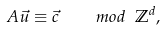Convert formula to latex. <formula><loc_0><loc_0><loc_500><loc_500>A \vec { u } \equiv \vec { c } \quad m o d \ \mathbb { Z } ^ { d } ,</formula> 